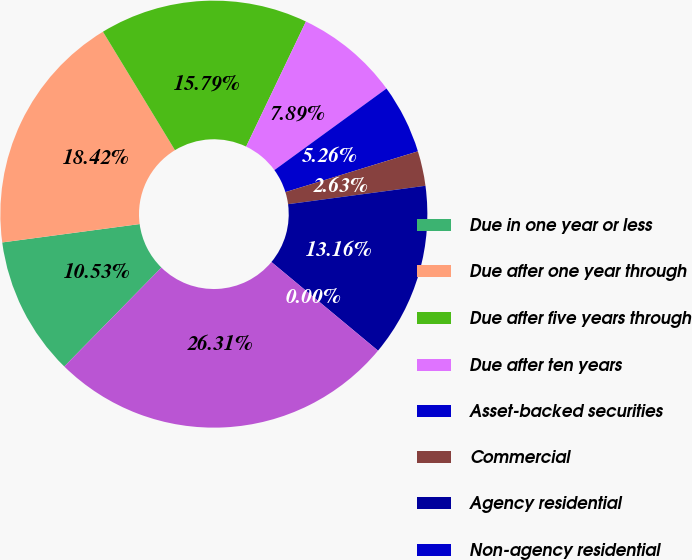<chart> <loc_0><loc_0><loc_500><loc_500><pie_chart><fcel>Due in one year or less<fcel>Due after one year through<fcel>Due after five years through<fcel>Due after ten years<fcel>Asset-backed securities<fcel>Commercial<fcel>Agency residential<fcel>Non-agency residential<fcel>Total fixed maturity<nl><fcel>10.53%<fcel>18.42%<fcel>15.79%<fcel>7.89%<fcel>5.26%<fcel>2.63%<fcel>13.16%<fcel>0.0%<fcel>26.31%<nl></chart> 